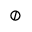<formula> <loc_0><loc_0><loc_500><loc_500>\oslash</formula> 